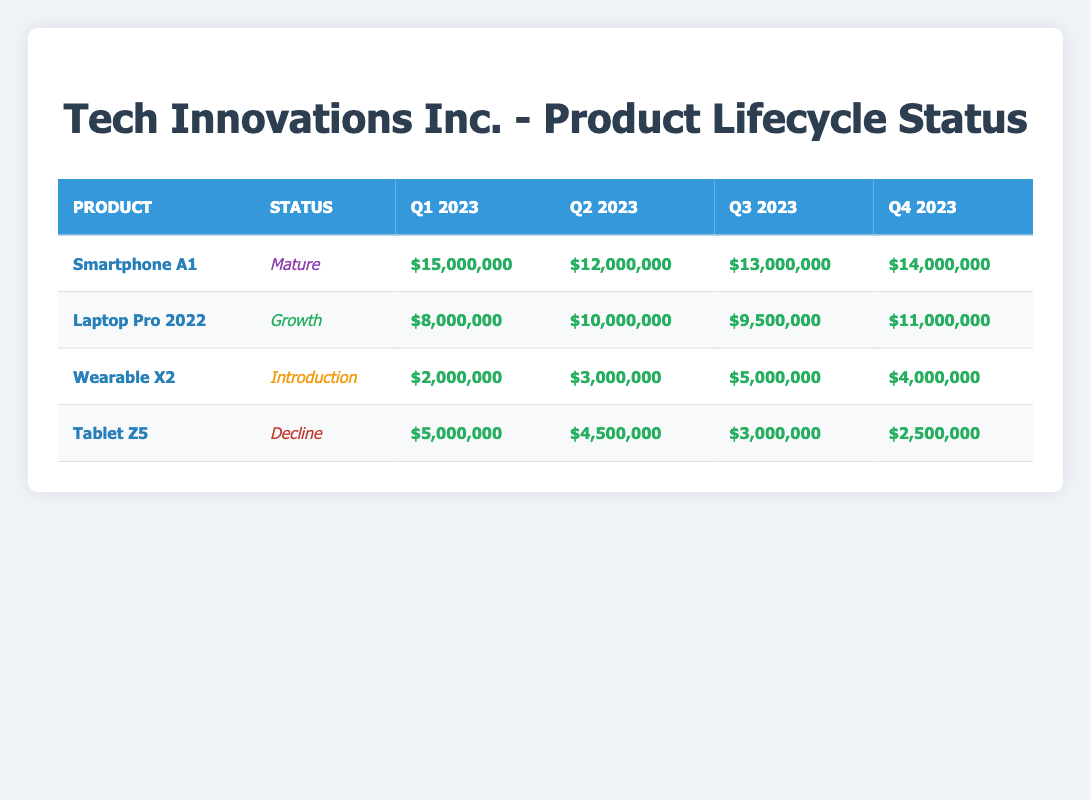What is the revenue contribution of Smartphone A1 in Q2 2023? According to the table, the revenue contribution for Smartphone A1 in Q2 2023 is listed as $12,000,000.
Answer: $12,000,000 Which product has the highest revenue contribution in Q3 2023? By comparing the revenue contributions for each product in Q3 2023, we find Smartphone A1 at $13,000,000, Laptop Pro 2022 at $9,500,000, Wearable X2 at $5,000,000, and Tablet Z5 at $3,000,000. Therefore, Smartphone A1 has the highest revenue contribution.
Answer: Smartphone A1 What is the total revenue contributed by Tablet Z5 throughout 2023? To find the total revenue for Tablet Z5, we need to sum the revenue contributions for each quarter: Q1 ($5,000,000) + Q2 ($4,500,000) + Q3 ($3,000,000) + Q4 ($2,500,000) = $15,000,000.
Answer: $15,000,000 Is the Wearable X2 in a mature or introduction stage according to its status? The table specifically lists Wearable X2 as being in the "Introduction" stage, indicating it is new to the market.
Answer: Introduction What is the average revenue contribution of all products in Q1 2023? To calculate the average revenue in Q1 2023, sum the values: Smartphone A1 ($15,000,000) + Laptop Pro 2022 ($8,000,000) + Wearable X2 ($2,000,000) + Tablet Z5 ($5,000,000) = $30,000,000. Then divide by the number of products (4), resulting in an average revenue of $30,000,000 / 4 = $7,500,000.
Answer: $7,500,000 In which quarter did the Laptop Pro 2022 achieve its highest revenue contribution? Looking at the revenue contributions listed for Laptop Pro 2022, we see Q1 ($8,000,000), Q2 ($10,000,000), Q3 ($9,500,000), and Q4 ($11,000,000). The highest revenue contribution is in Q4 2023.
Answer: Q4 2023 What was the revenue contribution of Tablet Z5 in Q3 2023? The table shows the revenue contribution for Tablet Z5 in Q3 2023 as $3,000,000.
Answer: $3,000,000 Did any product experience a decline in revenue contribution throughout 2023? Analyzing the revenue contributions, Tablet Z5 shows a decline from $5,000,000 in Q1 to $2,500,000 in Q4. This indicates a decline in revenue.
Answer: Yes 